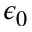Convert formula to latex. <formula><loc_0><loc_0><loc_500><loc_500>\epsilon _ { 0 }</formula> 